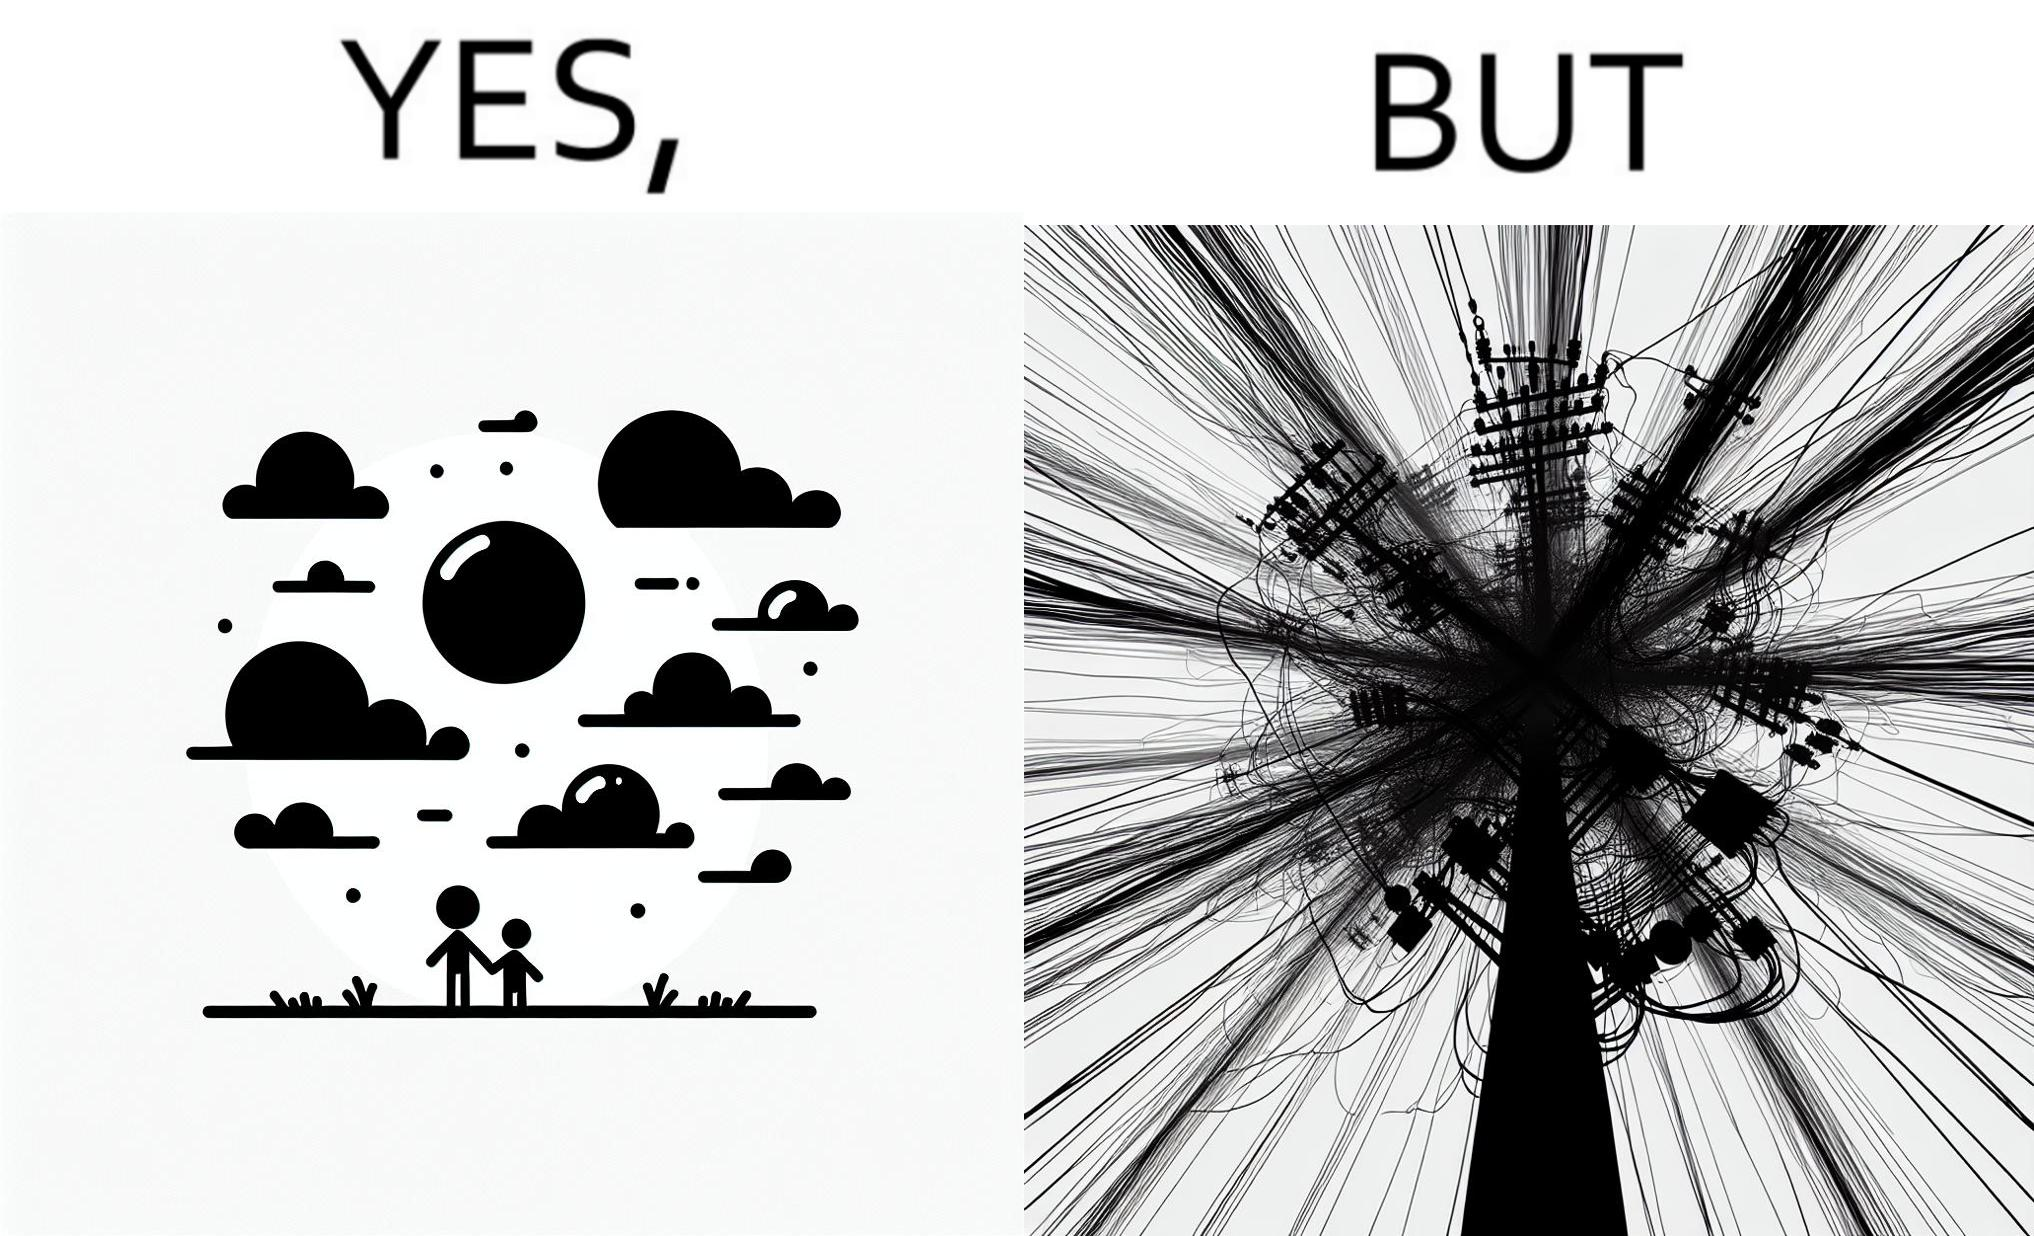What is the satirical meaning behind this image? The image is ironic, because in the first image clear sky is visible but in the second image the same view is getting blocked due to the electricity pole 